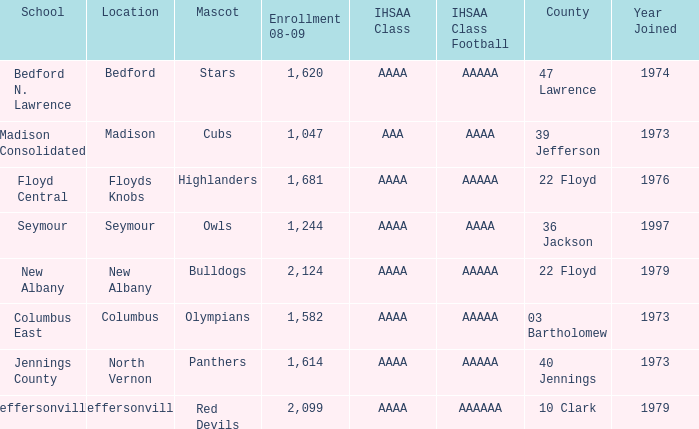What educational establishment can be found at 36 jackson? Seymour. 